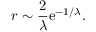Convert formula to latex. <formula><loc_0><loc_0><loc_500><loc_500>r \sim \frac { 2 } { \lambda } e ^ { - 1 / \lambda } .</formula> 